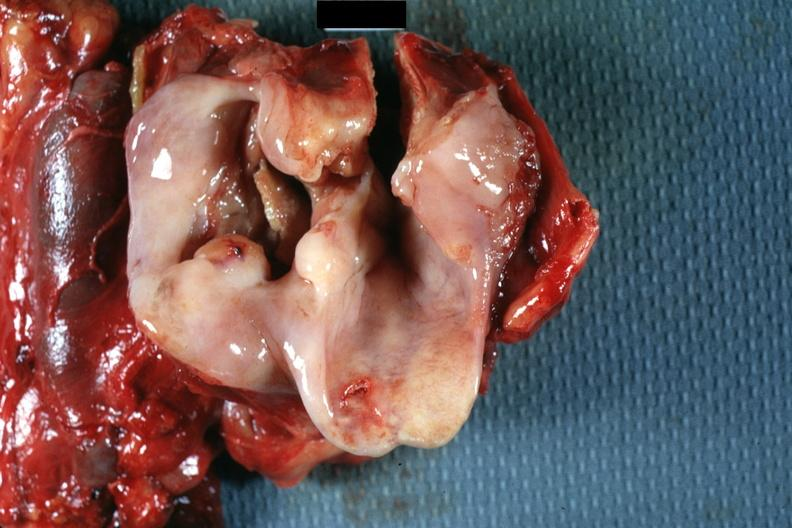what is present?
Answer the question using a single word or phrase. Squamous cell carcinoma 